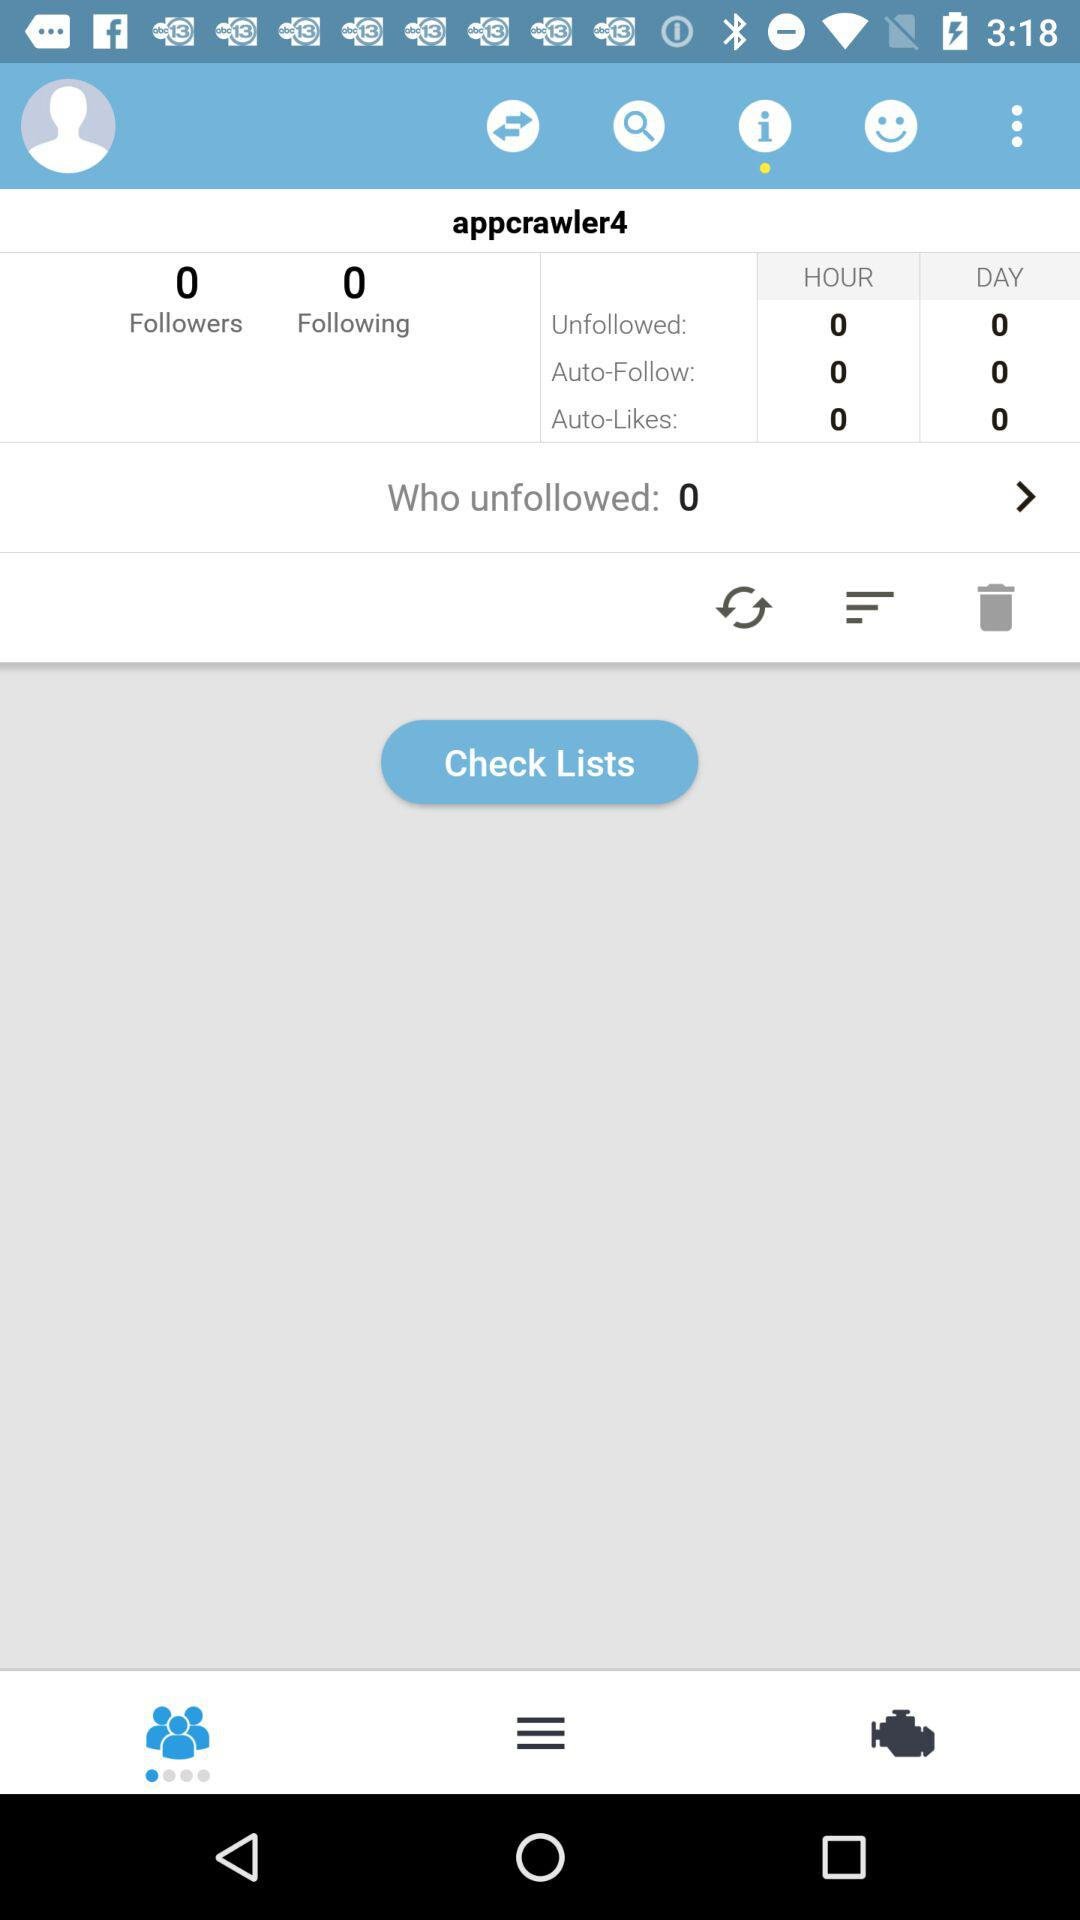How many people is the person following? The person is not following anyone. 